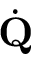Convert formula to latex. <formula><loc_0><loc_0><loc_500><loc_500>\dot { Q }</formula> 